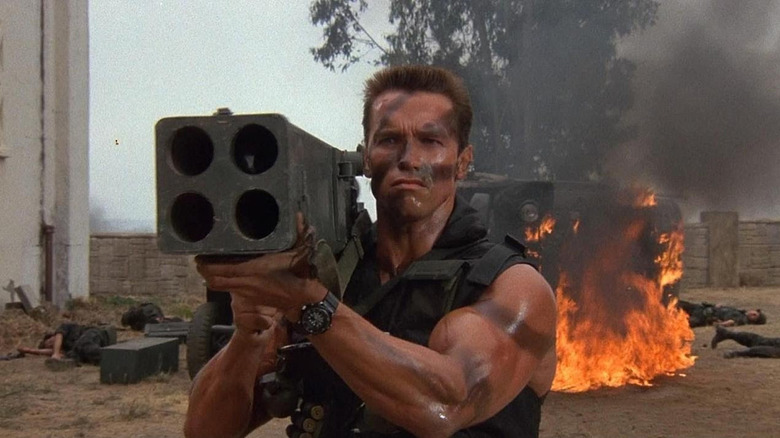How does the setting contribute to the overall intensity of the scene? The setting of smoldering ruins and billowing smoke dramatically heightens the scene's intensity. It visually communicates chaos and destruction, framing the character as a pivotal figure within this high-stakes environment, possibly the last line of defense in a dire situation. 